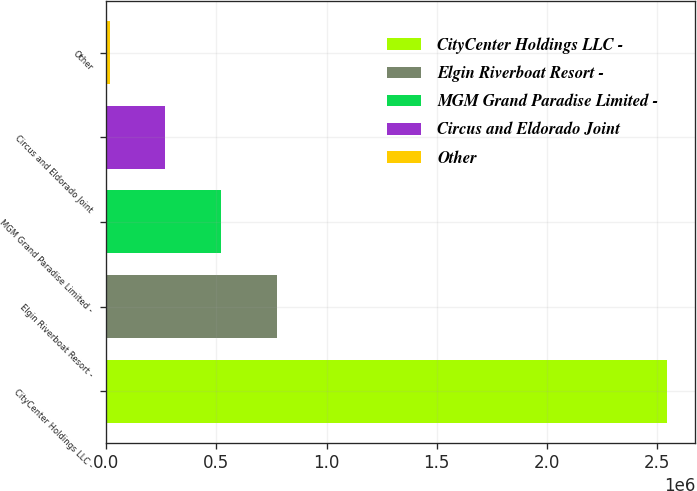Convert chart. <chart><loc_0><loc_0><loc_500><loc_500><bar_chart><fcel>CityCenter Holdings LLC -<fcel>Elgin Riverboat Resort -<fcel>MGM Grand Paradise Limited -<fcel>Circus and Eldorado Joint<fcel>Other<nl><fcel>2.5461e+06<fcel>774937<fcel>521914<fcel>268891<fcel>15868<nl></chart> 